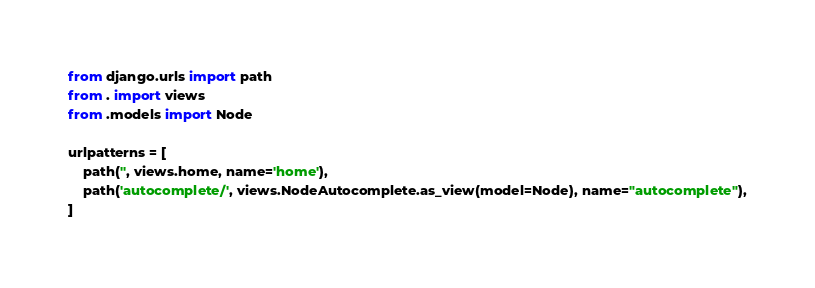<code> <loc_0><loc_0><loc_500><loc_500><_Python_>from django.urls import path
from . import views
from .models import Node

urlpatterns = [
    path('', views.home, name='home'),
    path('autocomplete/', views.NodeAutocomplete.as_view(model=Node), name="autocomplete"),
]
</code> 